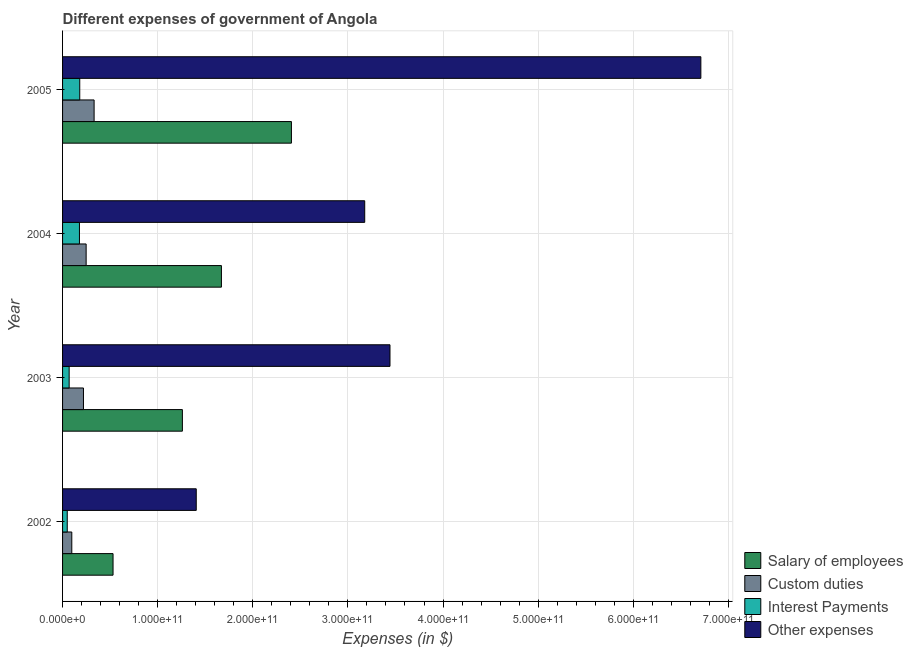How many different coloured bars are there?
Your response must be concise. 4. How many groups of bars are there?
Ensure brevity in your answer.  4. Are the number of bars per tick equal to the number of legend labels?
Provide a succinct answer. Yes. Are the number of bars on each tick of the Y-axis equal?
Provide a succinct answer. Yes. How many bars are there on the 2nd tick from the top?
Offer a terse response. 4. What is the label of the 1st group of bars from the top?
Provide a succinct answer. 2005. What is the amount spent on other expenses in 2002?
Provide a succinct answer. 1.41e+11. Across all years, what is the maximum amount spent on custom duties?
Make the answer very short. 3.32e+1. Across all years, what is the minimum amount spent on interest payments?
Ensure brevity in your answer.  4.92e+09. What is the total amount spent on custom duties in the graph?
Provide a short and direct response. 8.96e+1. What is the difference between the amount spent on interest payments in 2002 and that in 2004?
Your answer should be compact. -1.28e+1. What is the difference between the amount spent on interest payments in 2002 and the amount spent on other expenses in 2005?
Your answer should be compact. -6.66e+11. What is the average amount spent on salary of employees per year?
Offer a very short reply. 1.47e+11. In the year 2005, what is the difference between the amount spent on salary of employees and amount spent on other expenses?
Your response must be concise. -4.30e+11. What is the ratio of the amount spent on interest payments in 2004 to that in 2005?
Give a very brief answer. 0.98. Is the amount spent on custom duties in 2002 less than that in 2003?
Ensure brevity in your answer.  Yes. Is the difference between the amount spent on salary of employees in 2002 and 2005 greater than the difference between the amount spent on other expenses in 2002 and 2005?
Provide a short and direct response. Yes. What is the difference between the highest and the second highest amount spent on interest payments?
Keep it short and to the point. 3.18e+08. What is the difference between the highest and the lowest amount spent on other expenses?
Offer a very short reply. 5.31e+11. In how many years, is the amount spent on other expenses greater than the average amount spent on other expenses taken over all years?
Provide a succinct answer. 1. Is the sum of the amount spent on interest payments in 2004 and 2005 greater than the maximum amount spent on custom duties across all years?
Offer a very short reply. Yes. What does the 2nd bar from the top in 2005 represents?
Make the answer very short. Interest Payments. What does the 2nd bar from the bottom in 2002 represents?
Offer a very short reply. Custom duties. What is the difference between two consecutive major ticks on the X-axis?
Keep it short and to the point. 1.00e+11. Where does the legend appear in the graph?
Give a very brief answer. Bottom right. How many legend labels are there?
Offer a very short reply. 4. What is the title of the graph?
Offer a terse response. Different expenses of government of Angola. Does "Secondary general" appear as one of the legend labels in the graph?
Your answer should be very brief. No. What is the label or title of the X-axis?
Your answer should be compact. Expenses (in $). What is the Expenses (in $) in Salary of employees in 2002?
Keep it short and to the point. 5.31e+1. What is the Expenses (in $) of Custom duties in 2002?
Give a very brief answer. 9.70e+09. What is the Expenses (in $) of Interest Payments in 2002?
Ensure brevity in your answer.  4.92e+09. What is the Expenses (in $) in Other expenses in 2002?
Offer a very short reply. 1.41e+11. What is the Expenses (in $) in Salary of employees in 2003?
Your answer should be very brief. 1.26e+11. What is the Expenses (in $) in Custom duties in 2003?
Offer a very short reply. 2.20e+1. What is the Expenses (in $) in Interest Payments in 2003?
Provide a short and direct response. 6.93e+09. What is the Expenses (in $) of Other expenses in 2003?
Your answer should be compact. 3.44e+11. What is the Expenses (in $) in Salary of employees in 2004?
Provide a succinct answer. 1.67e+11. What is the Expenses (in $) of Custom duties in 2004?
Offer a very short reply. 2.48e+1. What is the Expenses (in $) of Interest Payments in 2004?
Your answer should be very brief. 1.78e+1. What is the Expenses (in $) in Other expenses in 2004?
Keep it short and to the point. 3.18e+11. What is the Expenses (in $) of Salary of employees in 2005?
Keep it short and to the point. 2.41e+11. What is the Expenses (in $) of Custom duties in 2005?
Your response must be concise. 3.32e+1. What is the Expenses (in $) in Interest Payments in 2005?
Keep it short and to the point. 1.81e+1. What is the Expenses (in $) in Other expenses in 2005?
Make the answer very short. 6.71e+11. Across all years, what is the maximum Expenses (in $) in Salary of employees?
Keep it short and to the point. 2.41e+11. Across all years, what is the maximum Expenses (in $) in Custom duties?
Ensure brevity in your answer.  3.32e+1. Across all years, what is the maximum Expenses (in $) of Interest Payments?
Provide a short and direct response. 1.81e+1. Across all years, what is the maximum Expenses (in $) of Other expenses?
Make the answer very short. 6.71e+11. Across all years, what is the minimum Expenses (in $) of Salary of employees?
Offer a very short reply. 5.31e+1. Across all years, what is the minimum Expenses (in $) of Custom duties?
Give a very brief answer. 9.70e+09. Across all years, what is the minimum Expenses (in $) of Interest Payments?
Provide a short and direct response. 4.92e+09. Across all years, what is the minimum Expenses (in $) of Other expenses?
Your answer should be compact. 1.41e+11. What is the total Expenses (in $) in Salary of employees in the graph?
Give a very brief answer. 5.87e+11. What is the total Expenses (in $) in Custom duties in the graph?
Ensure brevity in your answer.  8.96e+1. What is the total Expenses (in $) of Interest Payments in the graph?
Provide a short and direct response. 4.77e+1. What is the total Expenses (in $) of Other expenses in the graph?
Offer a very short reply. 1.47e+12. What is the difference between the Expenses (in $) in Salary of employees in 2002 and that in 2003?
Ensure brevity in your answer.  -7.29e+1. What is the difference between the Expenses (in $) in Custom duties in 2002 and that in 2003?
Offer a very short reply. -1.23e+1. What is the difference between the Expenses (in $) in Interest Payments in 2002 and that in 2003?
Provide a succinct answer. -2.02e+09. What is the difference between the Expenses (in $) in Other expenses in 2002 and that in 2003?
Provide a short and direct response. -2.04e+11. What is the difference between the Expenses (in $) of Salary of employees in 2002 and that in 2004?
Ensure brevity in your answer.  -1.14e+11. What is the difference between the Expenses (in $) in Custom duties in 2002 and that in 2004?
Provide a short and direct response. -1.51e+1. What is the difference between the Expenses (in $) in Interest Payments in 2002 and that in 2004?
Your answer should be very brief. -1.28e+1. What is the difference between the Expenses (in $) in Other expenses in 2002 and that in 2004?
Provide a succinct answer. -1.77e+11. What is the difference between the Expenses (in $) of Salary of employees in 2002 and that in 2005?
Ensure brevity in your answer.  -1.88e+11. What is the difference between the Expenses (in $) of Custom duties in 2002 and that in 2005?
Ensure brevity in your answer.  -2.35e+1. What is the difference between the Expenses (in $) in Interest Payments in 2002 and that in 2005?
Make the answer very short. -1.31e+1. What is the difference between the Expenses (in $) in Other expenses in 2002 and that in 2005?
Offer a terse response. -5.31e+11. What is the difference between the Expenses (in $) in Salary of employees in 2003 and that in 2004?
Ensure brevity in your answer.  -4.11e+1. What is the difference between the Expenses (in $) of Custom duties in 2003 and that in 2004?
Offer a terse response. -2.82e+09. What is the difference between the Expenses (in $) of Interest Payments in 2003 and that in 2004?
Make the answer very short. -1.08e+1. What is the difference between the Expenses (in $) in Other expenses in 2003 and that in 2004?
Offer a terse response. 2.66e+1. What is the difference between the Expenses (in $) of Salary of employees in 2003 and that in 2005?
Your response must be concise. -1.15e+11. What is the difference between the Expenses (in $) in Custom duties in 2003 and that in 2005?
Offer a very short reply. -1.12e+1. What is the difference between the Expenses (in $) in Interest Payments in 2003 and that in 2005?
Offer a terse response. -1.11e+1. What is the difference between the Expenses (in $) of Other expenses in 2003 and that in 2005?
Make the answer very short. -3.27e+11. What is the difference between the Expenses (in $) in Salary of employees in 2004 and that in 2005?
Provide a succinct answer. -7.36e+1. What is the difference between the Expenses (in $) in Custom duties in 2004 and that in 2005?
Your response must be concise. -8.36e+09. What is the difference between the Expenses (in $) in Interest Payments in 2004 and that in 2005?
Make the answer very short. -3.18e+08. What is the difference between the Expenses (in $) of Other expenses in 2004 and that in 2005?
Ensure brevity in your answer.  -3.53e+11. What is the difference between the Expenses (in $) of Salary of employees in 2002 and the Expenses (in $) of Custom duties in 2003?
Your answer should be very brief. 3.11e+1. What is the difference between the Expenses (in $) of Salary of employees in 2002 and the Expenses (in $) of Interest Payments in 2003?
Make the answer very short. 4.61e+1. What is the difference between the Expenses (in $) of Salary of employees in 2002 and the Expenses (in $) of Other expenses in 2003?
Give a very brief answer. -2.91e+11. What is the difference between the Expenses (in $) in Custom duties in 2002 and the Expenses (in $) in Interest Payments in 2003?
Provide a succinct answer. 2.77e+09. What is the difference between the Expenses (in $) in Custom duties in 2002 and the Expenses (in $) in Other expenses in 2003?
Offer a very short reply. -3.35e+11. What is the difference between the Expenses (in $) of Interest Payments in 2002 and the Expenses (in $) of Other expenses in 2003?
Provide a succinct answer. -3.39e+11. What is the difference between the Expenses (in $) of Salary of employees in 2002 and the Expenses (in $) of Custom duties in 2004?
Provide a short and direct response. 2.83e+1. What is the difference between the Expenses (in $) in Salary of employees in 2002 and the Expenses (in $) in Interest Payments in 2004?
Provide a short and direct response. 3.53e+1. What is the difference between the Expenses (in $) in Salary of employees in 2002 and the Expenses (in $) in Other expenses in 2004?
Your answer should be very brief. -2.65e+11. What is the difference between the Expenses (in $) of Custom duties in 2002 and the Expenses (in $) of Interest Payments in 2004?
Offer a terse response. -8.05e+09. What is the difference between the Expenses (in $) of Custom duties in 2002 and the Expenses (in $) of Other expenses in 2004?
Ensure brevity in your answer.  -3.08e+11. What is the difference between the Expenses (in $) of Interest Payments in 2002 and the Expenses (in $) of Other expenses in 2004?
Your response must be concise. -3.13e+11. What is the difference between the Expenses (in $) in Salary of employees in 2002 and the Expenses (in $) in Custom duties in 2005?
Provide a succinct answer. 1.99e+1. What is the difference between the Expenses (in $) of Salary of employees in 2002 and the Expenses (in $) of Interest Payments in 2005?
Keep it short and to the point. 3.50e+1. What is the difference between the Expenses (in $) in Salary of employees in 2002 and the Expenses (in $) in Other expenses in 2005?
Offer a very short reply. -6.18e+11. What is the difference between the Expenses (in $) of Custom duties in 2002 and the Expenses (in $) of Interest Payments in 2005?
Provide a short and direct response. -8.37e+09. What is the difference between the Expenses (in $) in Custom duties in 2002 and the Expenses (in $) in Other expenses in 2005?
Offer a terse response. -6.61e+11. What is the difference between the Expenses (in $) of Interest Payments in 2002 and the Expenses (in $) of Other expenses in 2005?
Offer a terse response. -6.66e+11. What is the difference between the Expenses (in $) in Salary of employees in 2003 and the Expenses (in $) in Custom duties in 2004?
Make the answer very short. 1.01e+11. What is the difference between the Expenses (in $) in Salary of employees in 2003 and the Expenses (in $) in Interest Payments in 2004?
Your answer should be compact. 1.08e+11. What is the difference between the Expenses (in $) of Salary of employees in 2003 and the Expenses (in $) of Other expenses in 2004?
Your response must be concise. -1.92e+11. What is the difference between the Expenses (in $) of Custom duties in 2003 and the Expenses (in $) of Interest Payments in 2004?
Offer a very short reply. 4.22e+09. What is the difference between the Expenses (in $) of Custom duties in 2003 and the Expenses (in $) of Other expenses in 2004?
Your response must be concise. -2.96e+11. What is the difference between the Expenses (in $) of Interest Payments in 2003 and the Expenses (in $) of Other expenses in 2004?
Give a very brief answer. -3.11e+11. What is the difference between the Expenses (in $) in Salary of employees in 2003 and the Expenses (in $) in Custom duties in 2005?
Give a very brief answer. 9.28e+1. What is the difference between the Expenses (in $) of Salary of employees in 2003 and the Expenses (in $) of Interest Payments in 2005?
Keep it short and to the point. 1.08e+11. What is the difference between the Expenses (in $) in Salary of employees in 2003 and the Expenses (in $) in Other expenses in 2005?
Offer a very short reply. -5.45e+11. What is the difference between the Expenses (in $) in Custom duties in 2003 and the Expenses (in $) in Interest Payments in 2005?
Keep it short and to the point. 3.90e+09. What is the difference between the Expenses (in $) of Custom duties in 2003 and the Expenses (in $) of Other expenses in 2005?
Ensure brevity in your answer.  -6.49e+11. What is the difference between the Expenses (in $) of Interest Payments in 2003 and the Expenses (in $) of Other expenses in 2005?
Give a very brief answer. -6.64e+11. What is the difference between the Expenses (in $) in Salary of employees in 2004 and the Expenses (in $) in Custom duties in 2005?
Offer a terse response. 1.34e+11. What is the difference between the Expenses (in $) in Salary of employees in 2004 and the Expenses (in $) in Interest Payments in 2005?
Ensure brevity in your answer.  1.49e+11. What is the difference between the Expenses (in $) of Salary of employees in 2004 and the Expenses (in $) of Other expenses in 2005?
Your response must be concise. -5.04e+11. What is the difference between the Expenses (in $) in Custom duties in 2004 and the Expenses (in $) in Interest Payments in 2005?
Offer a very short reply. 6.72e+09. What is the difference between the Expenses (in $) of Custom duties in 2004 and the Expenses (in $) of Other expenses in 2005?
Offer a terse response. -6.46e+11. What is the difference between the Expenses (in $) of Interest Payments in 2004 and the Expenses (in $) of Other expenses in 2005?
Ensure brevity in your answer.  -6.53e+11. What is the average Expenses (in $) of Salary of employees per year?
Give a very brief answer. 1.47e+11. What is the average Expenses (in $) of Custom duties per year?
Give a very brief answer. 2.24e+1. What is the average Expenses (in $) of Interest Payments per year?
Your response must be concise. 1.19e+1. What is the average Expenses (in $) of Other expenses per year?
Offer a terse response. 3.68e+11. In the year 2002, what is the difference between the Expenses (in $) of Salary of employees and Expenses (in $) of Custom duties?
Your answer should be very brief. 4.34e+1. In the year 2002, what is the difference between the Expenses (in $) in Salary of employees and Expenses (in $) in Interest Payments?
Offer a terse response. 4.82e+1. In the year 2002, what is the difference between the Expenses (in $) in Salary of employees and Expenses (in $) in Other expenses?
Your answer should be compact. -8.75e+1. In the year 2002, what is the difference between the Expenses (in $) of Custom duties and Expenses (in $) of Interest Payments?
Provide a succinct answer. 4.78e+09. In the year 2002, what is the difference between the Expenses (in $) in Custom duties and Expenses (in $) in Other expenses?
Your answer should be very brief. -1.31e+11. In the year 2002, what is the difference between the Expenses (in $) of Interest Payments and Expenses (in $) of Other expenses?
Make the answer very short. -1.36e+11. In the year 2003, what is the difference between the Expenses (in $) in Salary of employees and Expenses (in $) in Custom duties?
Offer a very short reply. 1.04e+11. In the year 2003, what is the difference between the Expenses (in $) in Salary of employees and Expenses (in $) in Interest Payments?
Offer a very short reply. 1.19e+11. In the year 2003, what is the difference between the Expenses (in $) in Salary of employees and Expenses (in $) in Other expenses?
Provide a succinct answer. -2.18e+11. In the year 2003, what is the difference between the Expenses (in $) of Custom duties and Expenses (in $) of Interest Payments?
Make the answer very short. 1.50e+1. In the year 2003, what is the difference between the Expenses (in $) of Custom duties and Expenses (in $) of Other expenses?
Provide a succinct answer. -3.22e+11. In the year 2003, what is the difference between the Expenses (in $) in Interest Payments and Expenses (in $) in Other expenses?
Keep it short and to the point. -3.37e+11. In the year 2004, what is the difference between the Expenses (in $) of Salary of employees and Expenses (in $) of Custom duties?
Your answer should be compact. 1.42e+11. In the year 2004, what is the difference between the Expenses (in $) of Salary of employees and Expenses (in $) of Interest Payments?
Provide a succinct answer. 1.49e+11. In the year 2004, what is the difference between the Expenses (in $) of Salary of employees and Expenses (in $) of Other expenses?
Provide a succinct answer. -1.51e+11. In the year 2004, what is the difference between the Expenses (in $) in Custom duties and Expenses (in $) in Interest Payments?
Provide a succinct answer. 7.04e+09. In the year 2004, what is the difference between the Expenses (in $) in Custom duties and Expenses (in $) in Other expenses?
Your response must be concise. -2.93e+11. In the year 2004, what is the difference between the Expenses (in $) in Interest Payments and Expenses (in $) in Other expenses?
Ensure brevity in your answer.  -3.00e+11. In the year 2005, what is the difference between the Expenses (in $) in Salary of employees and Expenses (in $) in Custom duties?
Your answer should be very brief. 2.07e+11. In the year 2005, what is the difference between the Expenses (in $) of Salary of employees and Expenses (in $) of Interest Payments?
Ensure brevity in your answer.  2.23e+11. In the year 2005, what is the difference between the Expenses (in $) of Salary of employees and Expenses (in $) of Other expenses?
Your answer should be compact. -4.30e+11. In the year 2005, what is the difference between the Expenses (in $) of Custom duties and Expenses (in $) of Interest Payments?
Give a very brief answer. 1.51e+1. In the year 2005, what is the difference between the Expenses (in $) in Custom duties and Expenses (in $) in Other expenses?
Ensure brevity in your answer.  -6.38e+11. In the year 2005, what is the difference between the Expenses (in $) of Interest Payments and Expenses (in $) of Other expenses?
Your answer should be very brief. -6.53e+11. What is the ratio of the Expenses (in $) in Salary of employees in 2002 to that in 2003?
Ensure brevity in your answer.  0.42. What is the ratio of the Expenses (in $) of Custom duties in 2002 to that in 2003?
Make the answer very short. 0.44. What is the ratio of the Expenses (in $) in Interest Payments in 2002 to that in 2003?
Your response must be concise. 0.71. What is the ratio of the Expenses (in $) of Other expenses in 2002 to that in 2003?
Make the answer very short. 0.41. What is the ratio of the Expenses (in $) of Salary of employees in 2002 to that in 2004?
Give a very brief answer. 0.32. What is the ratio of the Expenses (in $) in Custom duties in 2002 to that in 2004?
Provide a succinct answer. 0.39. What is the ratio of the Expenses (in $) in Interest Payments in 2002 to that in 2004?
Provide a succinct answer. 0.28. What is the ratio of the Expenses (in $) in Other expenses in 2002 to that in 2004?
Make the answer very short. 0.44. What is the ratio of the Expenses (in $) in Salary of employees in 2002 to that in 2005?
Your response must be concise. 0.22. What is the ratio of the Expenses (in $) of Custom duties in 2002 to that in 2005?
Keep it short and to the point. 0.29. What is the ratio of the Expenses (in $) of Interest Payments in 2002 to that in 2005?
Your response must be concise. 0.27. What is the ratio of the Expenses (in $) of Other expenses in 2002 to that in 2005?
Provide a succinct answer. 0.21. What is the ratio of the Expenses (in $) of Salary of employees in 2003 to that in 2004?
Give a very brief answer. 0.75. What is the ratio of the Expenses (in $) of Custom duties in 2003 to that in 2004?
Provide a short and direct response. 0.89. What is the ratio of the Expenses (in $) in Interest Payments in 2003 to that in 2004?
Provide a short and direct response. 0.39. What is the ratio of the Expenses (in $) of Other expenses in 2003 to that in 2004?
Give a very brief answer. 1.08. What is the ratio of the Expenses (in $) in Salary of employees in 2003 to that in 2005?
Your answer should be very brief. 0.52. What is the ratio of the Expenses (in $) of Custom duties in 2003 to that in 2005?
Your response must be concise. 0.66. What is the ratio of the Expenses (in $) in Interest Payments in 2003 to that in 2005?
Make the answer very short. 0.38. What is the ratio of the Expenses (in $) in Other expenses in 2003 to that in 2005?
Your answer should be compact. 0.51. What is the ratio of the Expenses (in $) of Salary of employees in 2004 to that in 2005?
Provide a short and direct response. 0.69. What is the ratio of the Expenses (in $) of Custom duties in 2004 to that in 2005?
Your answer should be very brief. 0.75. What is the ratio of the Expenses (in $) of Interest Payments in 2004 to that in 2005?
Your answer should be very brief. 0.98. What is the ratio of the Expenses (in $) of Other expenses in 2004 to that in 2005?
Ensure brevity in your answer.  0.47. What is the difference between the highest and the second highest Expenses (in $) of Salary of employees?
Your answer should be compact. 7.36e+1. What is the difference between the highest and the second highest Expenses (in $) of Custom duties?
Offer a very short reply. 8.36e+09. What is the difference between the highest and the second highest Expenses (in $) of Interest Payments?
Keep it short and to the point. 3.18e+08. What is the difference between the highest and the second highest Expenses (in $) in Other expenses?
Your answer should be compact. 3.27e+11. What is the difference between the highest and the lowest Expenses (in $) in Salary of employees?
Provide a succinct answer. 1.88e+11. What is the difference between the highest and the lowest Expenses (in $) of Custom duties?
Give a very brief answer. 2.35e+1. What is the difference between the highest and the lowest Expenses (in $) of Interest Payments?
Make the answer very short. 1.31e+1. What is the difference between the highest and the lowest Expenses (in $) in Other expenses?
Your answer should be compact. 5.31e+11. 